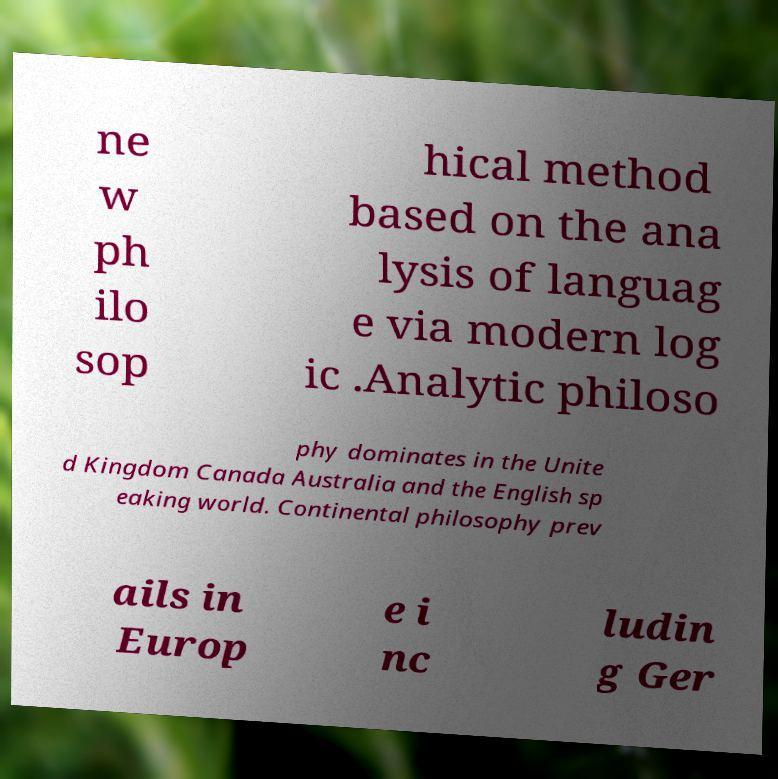Please read and relay the text visible in this image. What does it say? ne w ph ilo sop hical method based on the ana lysis of languag e via modern log ic .Analytic philoso phy dominates in the Unite d Kingdom Canada Australia and the English sp eaking world. Continental philosophy prev ails in Europ e i nc ludin g Ger 